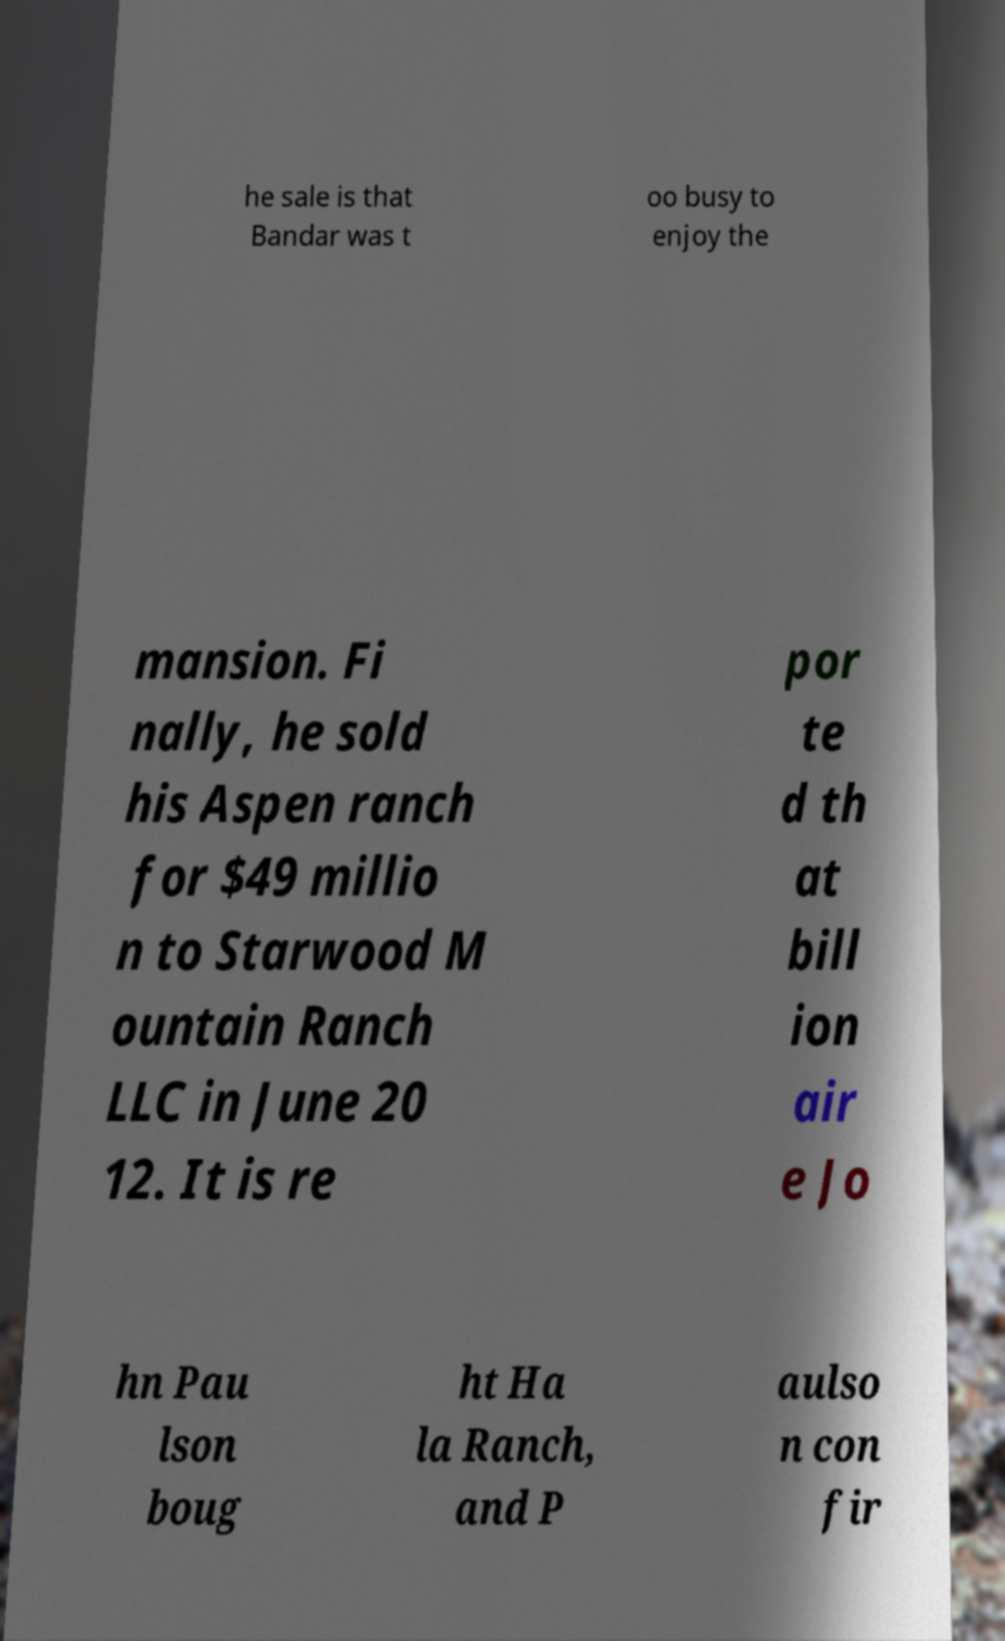Please read and relay the text visible in this image. What does it say? he sale is that Bandar was t oo busy to enjoy the mansion. Fi nally, he sold his Aspen ranch for $49 millio n to Starwood M ountain Ranch LLC in June 20 12. It is re por te d th at bill ion air e Jo hn Pau lson boug ht Ha la Ranch, and P aulso n con fir 